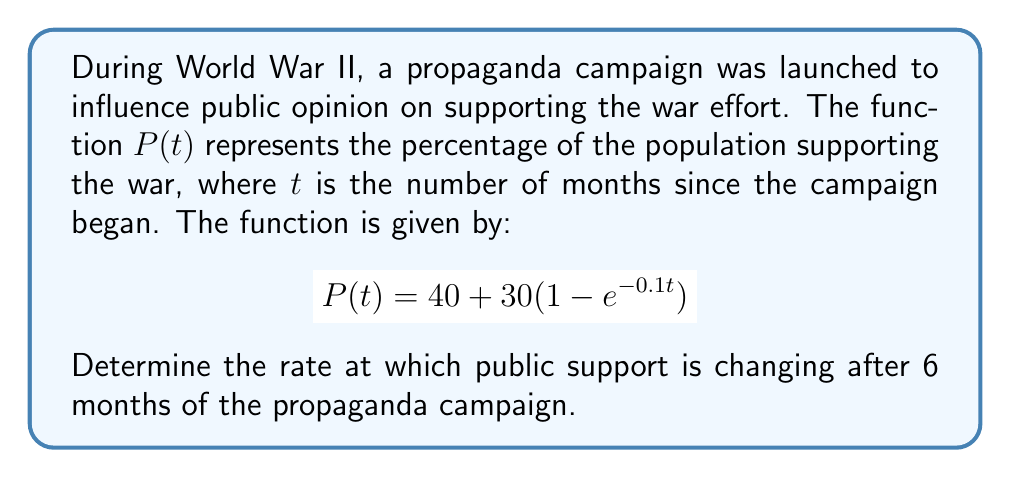Solve this math problem. To find the rate of change in public opinion after 6 months, we need to calculate the derivative of $P(t)$ and evaluate it at $t=6$. Let's follow these steps:

1) First, let's find the derivative of $P(t)$:
   $$\frac{d}{dt}P(t) = \frac{d}{dt}[40 + 30(1 - e^{-0.1t})]$$
   
   The constant term 40 disappears when we take the derivative:
   $$P'(t) = 30 \cdot \frac{d}{dt}(1 - e^{-0.1t})$$
   
   Using the chain rule:
   $$P'(t) = 30 \cdot (0 - (-0.1)e^{-0.1t})$$
   
   Simplifying:
   $$P'(t) = 3e^{-0.1t}$$

2) Now, we evaluate $P'(t)$ at $t=6$:
   $$P'(6) = 3e^{-0.1(6)}$$
   $$P'(6) = 3e^{-0.6}$$

3) Using a calculator or leaving it in this form:
   $$P'(6) \approx 1.647$$

This value represents the rate of change in percentage points per month after 6 months of the propaganda campaign.
Answer: $3e^{-0.6}$ percentage points per month 